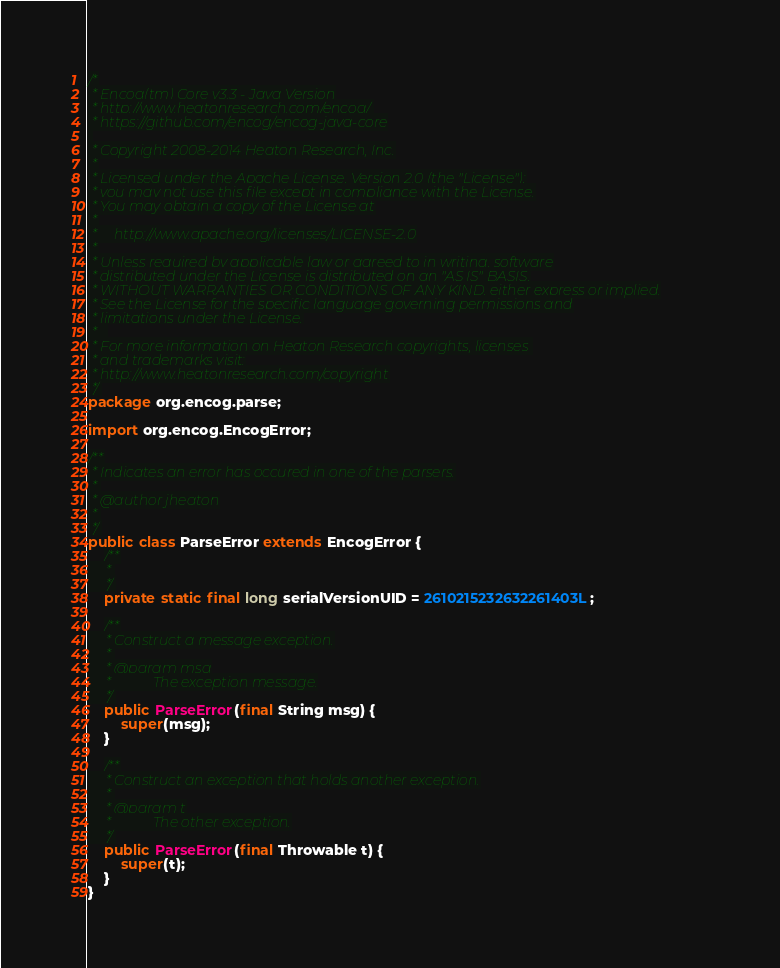<code> <loc_0><loc_0><loc_500><loc_500><_Java_>/*
 * Encog(tm) Core v3.3 - Java Version
 * http://www.heatonresearch.com/encog/
 * https://github.com/encog/encog-java-core
 
 * Copyright 2008-2014 Heaton Research, Inc.
 *
 * Licensed under the Apache License, Version 2.0 (the "License");
 * you may not use this file except in compliance with the License.
 * You may obtain a copy of the License at
 *
 *     http://www.apache.org/licenses/LICENSE-2.0
 *
 * Unless required by applicable law or agreed to in writing, software
 * distributed under the License is distributed on an "AS IS" BASIS,
 * WITHOUT WARRANTIES OR CONDITIONS OF ANY KIND, either express or implied.
 * See the License for the specific language governing permissions and
 * limitations under the License.
 *   
 * For more information on Heaton Research copyrights, licenses 
 * and trademarks visit:
 * http://www.heatonresearch.com/copyright
 */
package org.encog.parse;

import org.encog.EncogError;

/**
 * Indicates an error has occured in one of the parsers.
 * 
 * @author jheaton
 * 
 */
public class ParseError extends EncogError {
	/**
	 * 
	 */
	private static final long serialVersionUID = 2610215232632261403L;

	/**
	 * Construct a message exception.
	 * 
	 * @param msg
	 *            The exception message.
	 */
	public ParseError(final String msg) {
		super(msg);
	}

	/**
	 * Construct an exception that holds another exception.
	 * 
	 * @param t
	 *            The other exception.
	 */
	public ParseError(final Throwable t) {
		super(t);
	}
}
</code> 